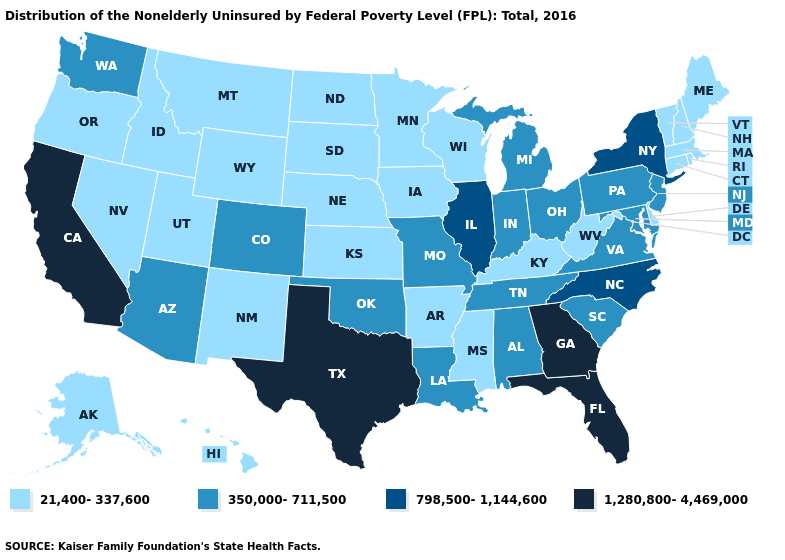What is the value of Kansas?
Short answer required. 21,400-337,600. What is the value of Montana?
Concise answer only. 21,400-337,600. What is the highest value in the USA?
Give a very brief answer. 1,280,800-4,469,000. What is the lowest value in the USA?
Write a very short answer. 21,400-337,600. What is the value of Colorado?
Short answer required. 350,000-711,500. Name the states that have a value in the range 21,400-337,600?
Write a very short answer. Alaska, Arkansas, Connecticut, Delaware, Hawaii, Idaho, Iowa, Kansas, Kentucky, Maine, Massachusetts, Minnesota, Mississippi, Montana, Nebraska, Nevada, New Hampshire, New Mexico, North Dakota, Oregon, Rhode Island, South Dakota, Utah, Vermont, West Virginia, Wisconsin, Wyoming. Name the states that have a value in the range 21,400-337,600?
Short answer required. Alaska, Arkansas, Connecticut, Delaware, Hawaii, Idaho, Iowa, Kansas, Kentucky, Maine, Massachusetts, Minnesota, Mississippi, Montana, Nebraska, Nevada, New Hampshire, New Mexico, North Dakota, Oregon, Rhode Island, South Dakota, Utah, Vermont, West Virginia, Wisconsin, Wyoming. Among the states that border Florida , which have the lowest value?
Keep it brief. Alabama. Is the legend a continuous bar?
Keep it brief. No. Name the states that have a value in the range 1,280,800-4,469,000?
Answer briefly. California, Florida, Georgia, Texas. Does Kentucky have the lowest value in the South?
Be succinct. Yes. Name the states that have a value in the range 21,400-337,600?
Quick response, please. Alaska, Arkansas, Connecticut, Delaware, Hawaii, Idaho, Iowa, Kansas, Kentucky, Maine, Massachusetts, Minnesota, Mississippi, Montana, Nebraska, Nevada, New Hampshire, New Mexico, North Dakota, Oregon, Rhode Island, South Dakota, Utah, Vermont, West Virginia, Wisconsin, Wyoming. Among the states that border Oklahoma , which have the lowest value?
Keep it brief. Arkansas, Kansas, New Mexico. Name the states that have a value in the range 350,000-711,500?
Be succinct. Alabama, Arizona, Colorado, Indiana, Louisiana, Maryland, Michigan, Missouri, New Jersey, Ohio, Oklahoma, Pennsylvania, South Carolina, Tennessee, Virginia, Washington. What is the highest value in the USA?
Quick response, please. 1,280,800-4,469,000. 